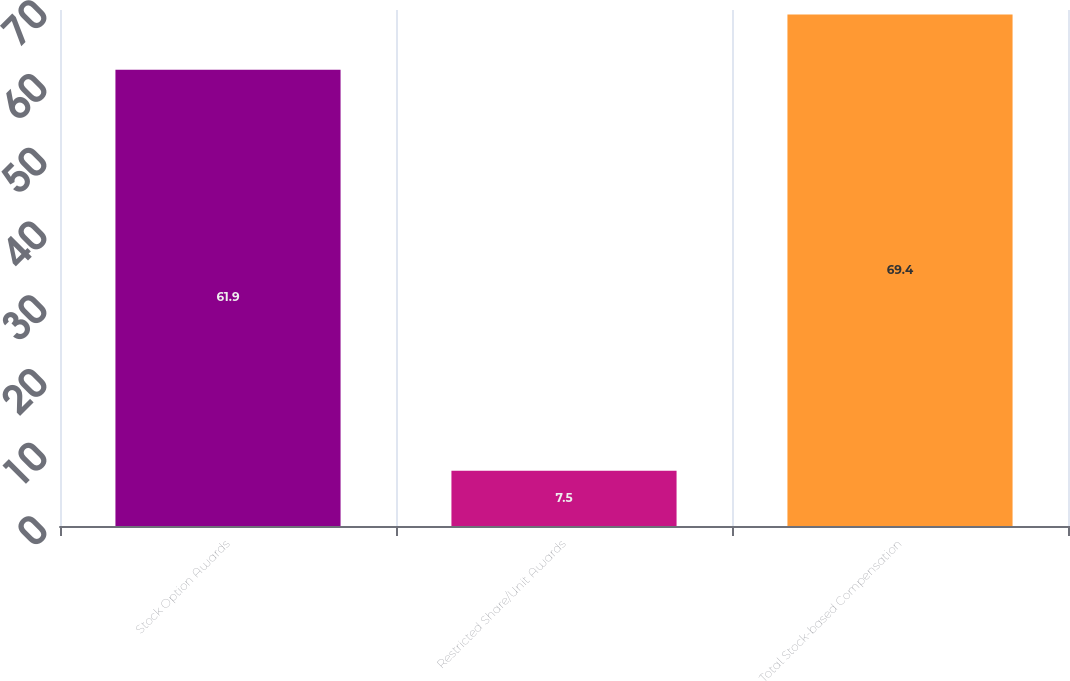Convert chart to OTSL. <chart><loc_0><loc_0><loc_500><loc_500><bar_chart><fcel>Stock Option Awards<fcel>Restricted Share/Unit Awards<fcel>Total Stock-based Compensation<nl><fcel>61.9<fcel>7.5<fcel>69.4<nl></chart> 